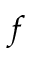Convert formula to latex. <formula><loc_0><loc_0><loc_500><loc_500>^ { f }</formula> 